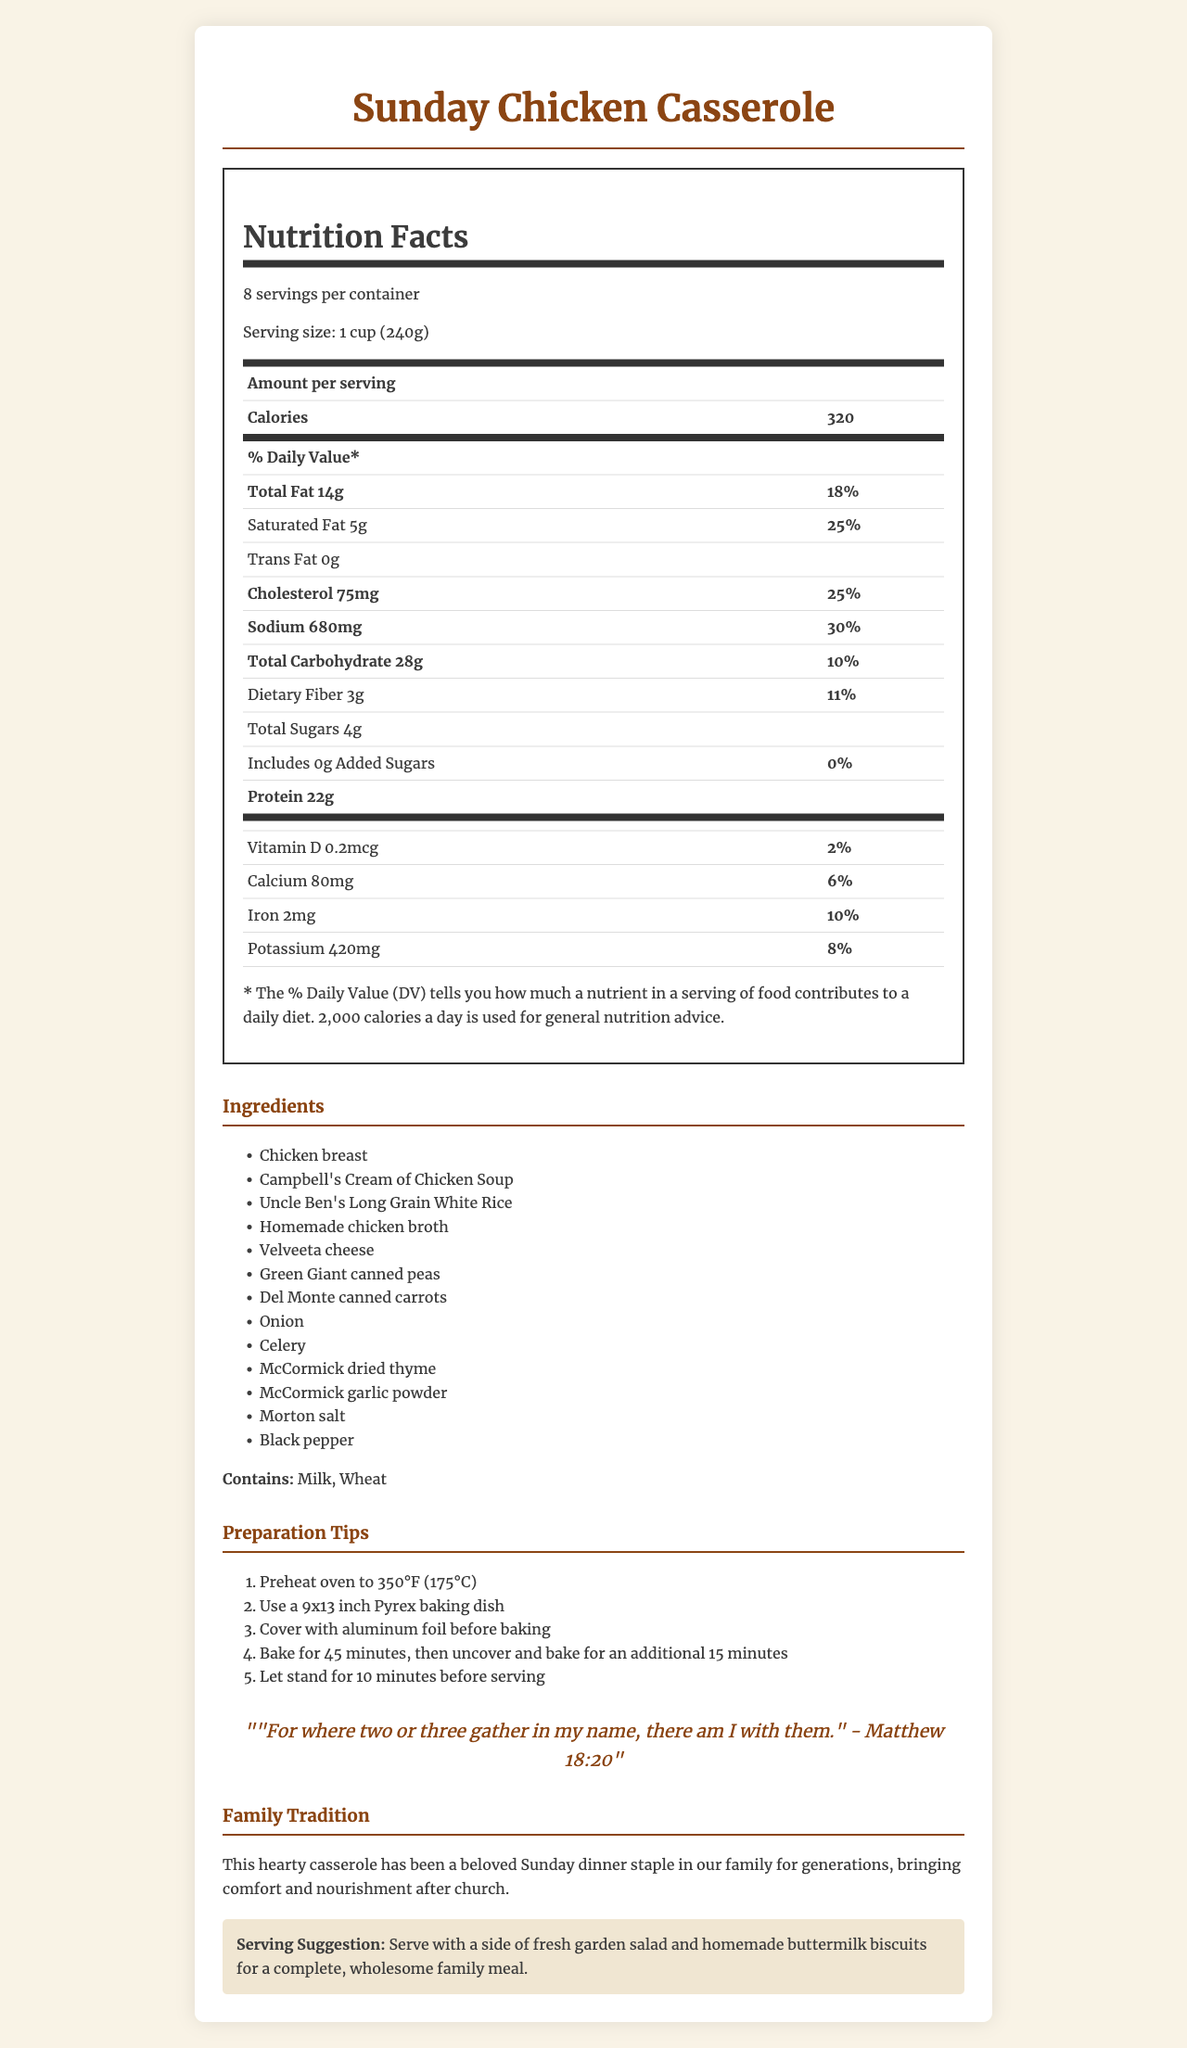what is the serving size per portion? The serving size is listed directly on the Nutrition Facts Label as "1 cup (240g)".
Answer: 1 cup (240g) how many servings are there per container? The Nutrition Facts Label specifies there are 8 servings per container.
Answer: 8 servings how many calories are there per serving? The document states that there are 320 calories per serving.
Answer: 320 calories what is the total fat content per serving, and what is its daily value percentage? The label lists the total fat content as 14g per serving with a daily value percentage of 18%.
Answer: 14g total fat, 18% daily value how much protein is in each serving? The protein content per serving is 22 grams, as listed in the Nutrition Facts section.
Answer: 22 grams what are the two major allergens in this dish? The document states that the allergens present are "Milk" and "Wheat".
Answer: Milk and Wheat what is the sodium content per serving, and what is its daily value percentage? The sodium content per serving is 680mg, which constitutes 30% of the daily value.
Answer: 680mg sodium, 30% daily value how long do you need to bake the casserole covered before uncovering it? A. 30 minutes B. 45 minutes C. 60 minutes D. 15 minutes The preparation tips section indicates that you should bake the casserole covered for 45 minutes.
Answer: B which scripture is used for inspiration in the document? A. John 3:16 B. Matthew 18:20 C. Psalm 23:1 D. Proverbs 31:10 The scripture inspiration quoted in the document is "For where two or three gather in my name, there am I with them." - Matthew 18:20.
Answer: B does this dish contain any added sugars? The document specifies that the dish contains 0g of added sugars.
Answer: No is this a high-fiber meal based on one serving size? The dietary fiber content is 3g per serving, which is 11% of the daily value, not qualifying as high fiber.
Answer: No please summarize the entire document. The document structures its nutritional information in a clear, easy-to-read format. It emphasizes the traditional and familial value of the dish, pairing it with religious scripture for inspiration and suggesting complementary sides for a wholesome meal.
Answer: This document provides detailed nutritional information for a family-sized portion of traditional Sunday chicken casserole. Key details include serving size (1 cup), servings per container (8), and various nutritional values such as calories (320 per serving), total fat (14g), and protein (22g). The ingredients list and allergens are also provided, along with preparation tips. The document highlights the dish's significance as a family tradition and includes a scripture inspiration from Matthew 18:20. A serving suggestion is also offered. what is the exact weight of the chicken used in the recipe? The document does not provide the exact weight of the chicken used in the recipe, only listing "Chicken breast" as an ingredient without further detail.
Answer: Cannot be determined 